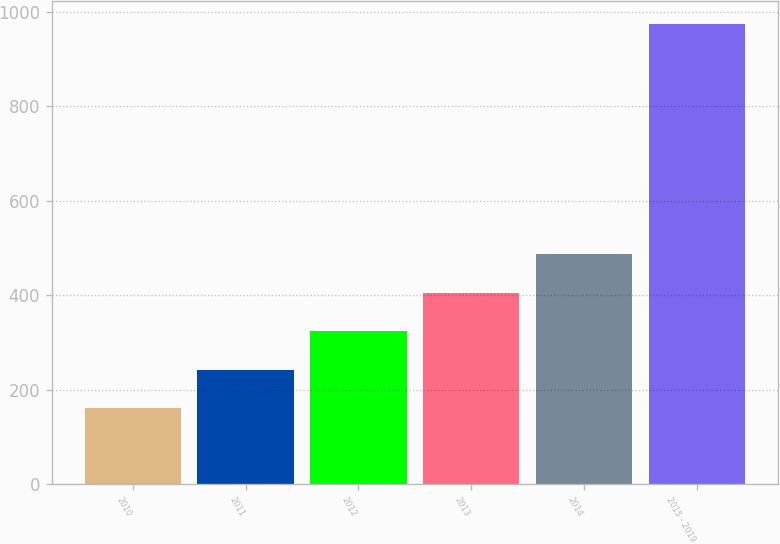Convert chart. <chart><loc_0><loc_0><loc_500><loc_500><bar_chart><fcel>2010<fcel>2011<fcel>2012<fcel>2013<fcel>2014<fcel>2015 - 2019<nl><fcel>161<fcel>242.3<fcel>323.6<fcel>404.9<fcel>486.2<fcel>974<nl></chart> 